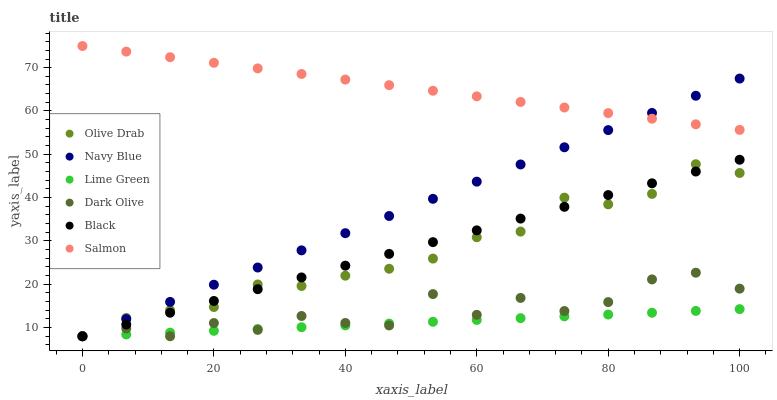Does Lime Green have the minimum area under the curve?
Answer yes or no. Yes. Does Salmon have the maximum area under the curve?
Answer yes or no. Yes. Does Dark Olive have the minimum area under the curve?
Answer yes or no. No. Does Dark Olive have the maximum area under the curve?
Answer yes or no. No. Is Lime Green the smoothest?
Answer yes or no. Yes. Is Dark Olive the roughest?
Answer yes or no. Yes. Is Salmon the smoothest?
Answer yes or no. No. Is Salmon the roughest?
Answer yes or no. No. Does Navy Blue have the lowest value?
Answer yes or no. Yes. Does Salmon have the lowest value?
Answer yes or no. No. Does Salmon have the highest value?
Answer yes or no. Yes. Does Dark Olive have the highest value?
Answer yes or no. No. Is Lime Green less than Salmon?
Answer yes or no. Yes. Is Salmon greater than Lime Green?
Answer yes or no. Yes. Does Olive Drab intersect Black?
Answer yes or no. Yes. Is Olive Drab less than Black?
Answer yes or no. No. Is Olive Drab greater than Black?
Answer yes or no. No. Does Lime Green intersect Salmon?
Answer yes or no. No. 